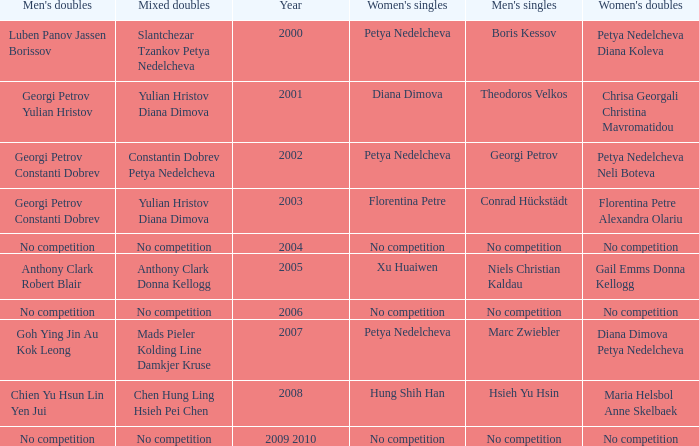Could you help me parse every detail presented in this table? {'header': ["Men's doubles", 'Mixed doubles', 'Year', "Women's singles", "Men's singles", "Women's doubles"], 'rows': [['Luben Panov Jassen Borissov', 'Slantchezar Tzankov Petya Nedelcheva', '2000', 'Petya Nedelcheva', 'Boris Kessov', 'Petya Nedelcheva Diana Koleva'], ['Georgi Petrov Yulian Hristov', 'Yulian Hristov Diana Dimova', '2001', 'Diana Dimova', 'Theodoros Velkos', 'Chrisa Georgali Christina Mavromatidou'], ['Georgi Petrov Constanti Dobrev', 'Constantin Dobrev Petya Nedelcheva', '2002', 'Petya Nedelcheva', 'Georgi Petrov', 'Petya Nedelcheva Neli Boteva'], ['Georgi Petrov Constanti Dobrev', 'Yulian Hristov Diana Dimova', '2003', 'Florentina Petre', 'Conrad Hückstädt', 'Florentina Petre Alexandra Olariu'], ['No competition', 'No competition', '2004', 'No competition', 'No competition', 'No competition'], ['Anthony Clark Robert Blair', 'Anthony Clark Donna Kellogg', '2005', 'Xu Huaiwen', 'Niels Christian Kaldau', 'Gail Emms Donna Kellogg'], ['No competition', 'No competition', '2006', 'No competition', 'No competition', 'No competition'], ['Goh Ying Jin Au Kok Leong', 'Mads Pieler Kolding Line Damkjer Kruse', '2007', 'Petya Nedelcheva', 'Marc Zwiebler', 'Diana Dimova Petya Nedelcheva'], ['Chien Yu Hsun Lin Yen Jui', 'Chen Hung Ling Hsieh Pei Chen', '2008', 'Hung Shih Han', 'Hsieh Yu Hsin', 'Maria Helsbol Anne Skelbaek'], ['No competition', 'No competition', '2009 2010', 'No competition', 'No competition', 'No competition']]} Who won the Men's Double the same year as Florentina Petre winning the Women's Singles? Georgi Petrov Constanti Dobrev. 